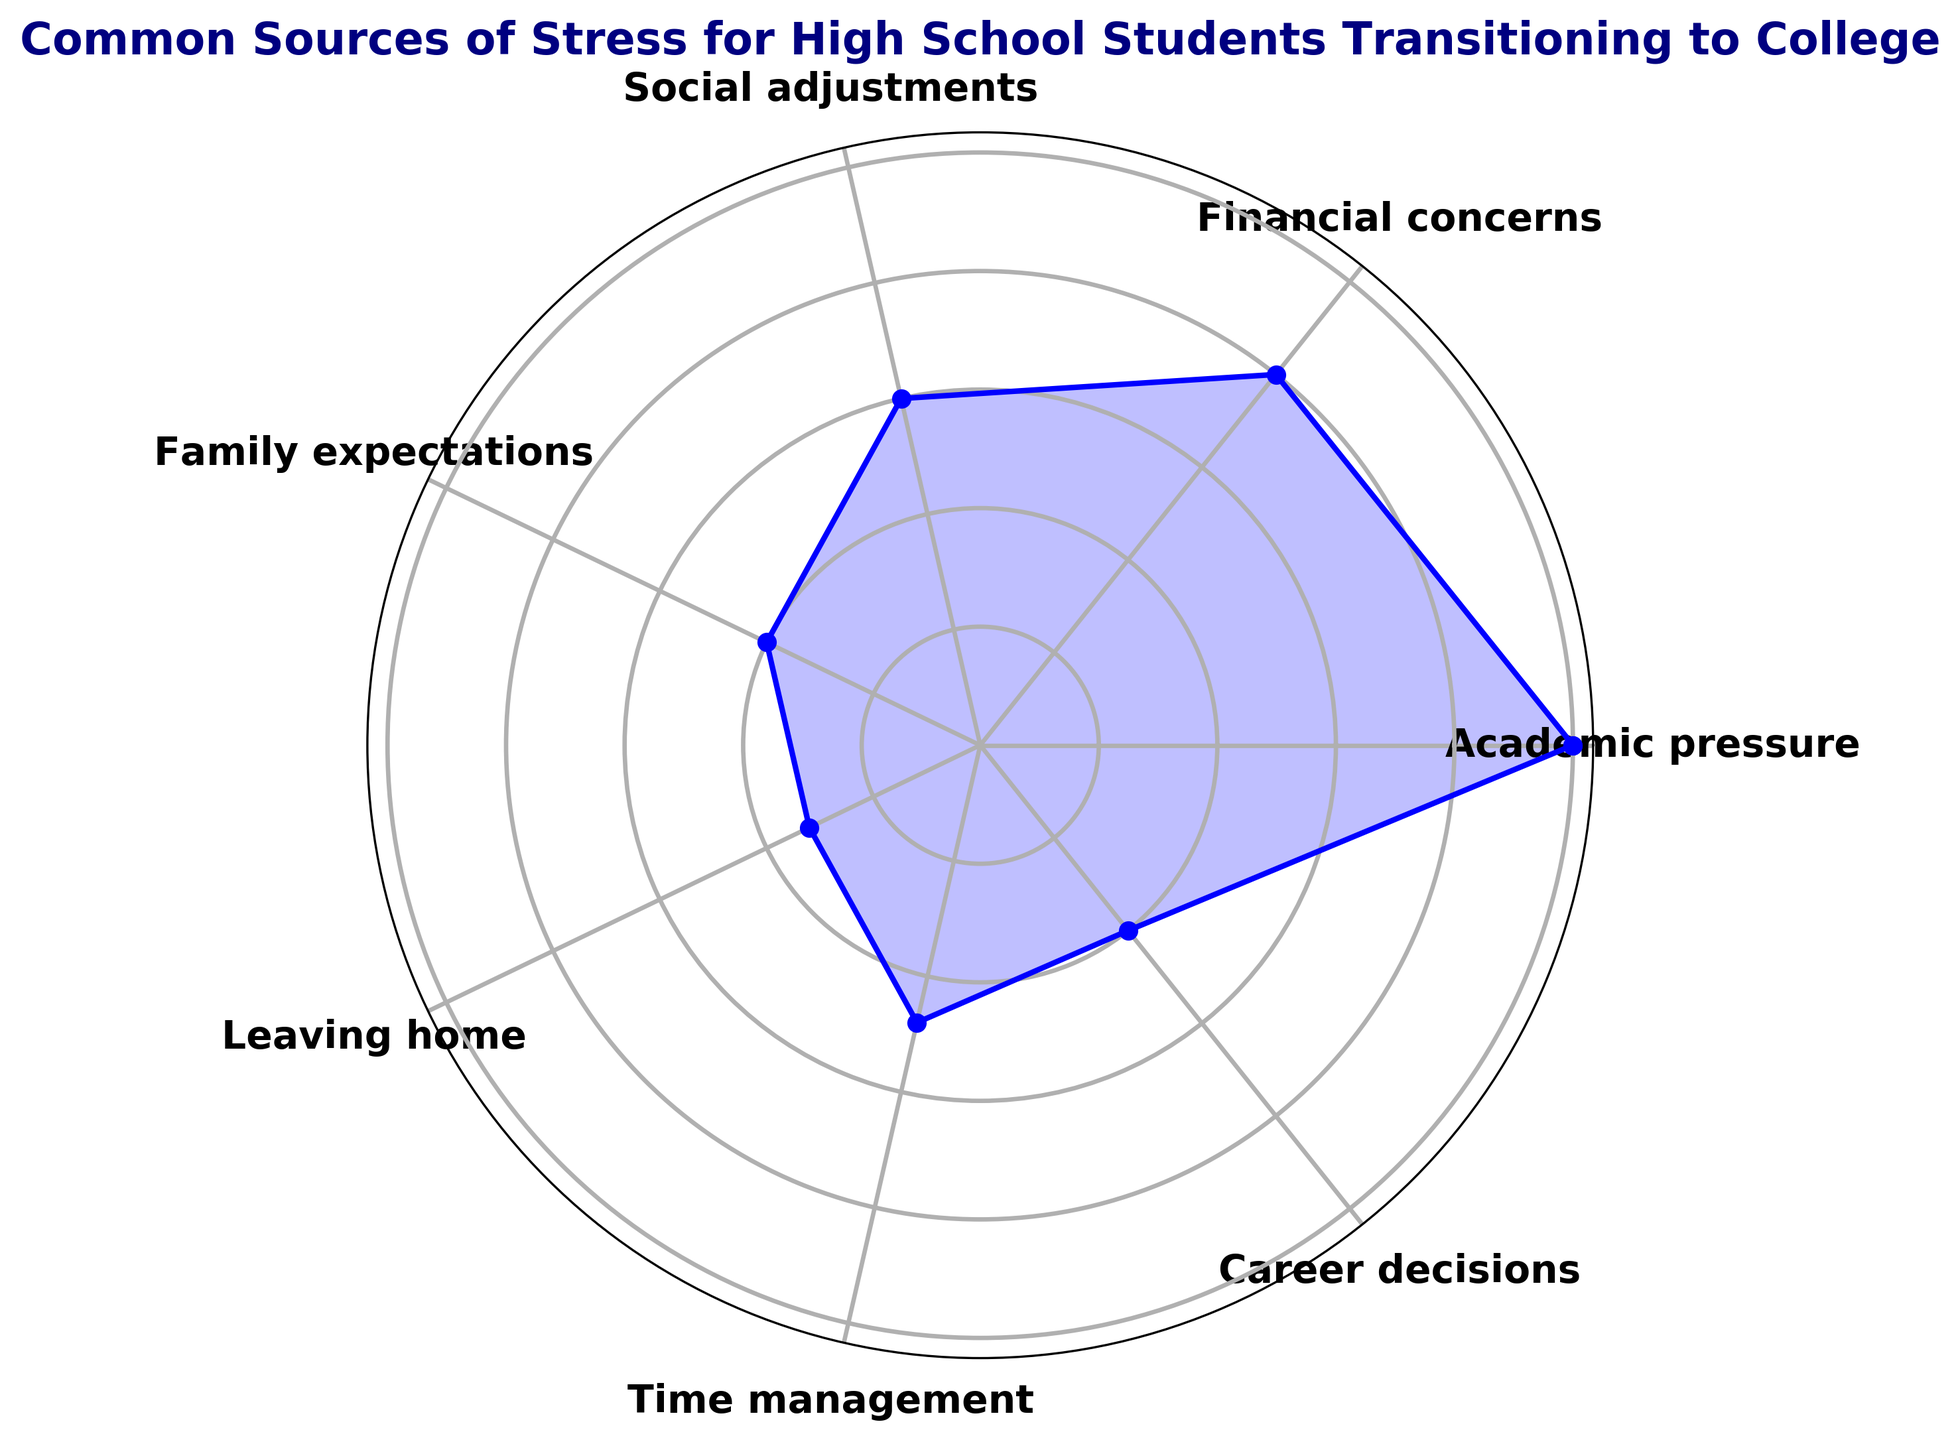What are the top three sources of stress for high school students transitioning to college? Identify the highest three stress levels from the chart. They are Academic pressure (25), Financial concerns (20), and Social adjustments (15).
Answer: Academic pressure, Financial concerns, Social adjustments Which source of stress is the least common among high school students transitioning to college? Determine the lowest stress level from the chart. The category with the lowest value is Leaving home (8).
Answer: Leaving home Is financial concern a more significant stressor than career decisions? Compare the stress levels of Financial concerns (20) and Career decisions (10). Since 20 is greater than 10, financial concerns are more significant.
Answer: Yes What is the difference in stress levels between Academic pressure and Time management? Subtract the stress level of Time management (12) from Academic pressure (25), the difference is 25 - 12 = 13.
Answer: 13 What is the combined stress level of Family expectations and Career decisions? Sum the stress levels of Family expectations (10) and Career decisions (10), the combined stress level is 10 + 10 = 20.
Answer: 20 How does the stress level of Social adjustments compare to Time management? Compare the stress levels of Social adjustments (15) and Time management (12). Since 15 is greater than 12, Social adjustments are a larger stressor.
Answer: Social adjustments is higher Which two categories have stress levels that add up to equal the stress level of Financial concerns? Find two categories whose combined stress levels equal Financial concerns (20). Family expectations (10) and Career decisions (10) add up to 20 (10 + 10).
Answer: Family expectations and Career decisions If the stress levels of Leaving home and Social adjustments are combined, do they exceed Academic pressure? Sum the stress levels of Leaving home (8) and Social adjustments (15) and compare the total (23) to Academic pressure (25). 23 is less than 25, so they do not exceed it.
Answer: No Rank the stress categories from highest to lowest. Organize the given stress categories according to their stress levels, from highest to lowest: Academic pressure (25), Financial concerns (20), Social adjustments (15), Time management (12), Family expectations (10), Career decisions (10), Leaving home (8).
Answer: Academic pressure, Financial concerns, Social adjustments, Time management, Family expectations, Career decisions, Leaving home What is the average stress level among all categories? Sum all stress levels (25 + 20 + 15 + 10 + 8 + 12 + 10 = 100) and divide by the number of categories (7). The average is 100 / 7 ≈ 14.29.
Answer: 14.29 